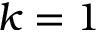Convert formula to latex. <formula><loc_0><loc_0><loc_500><loc_500>k = 1</formula> 